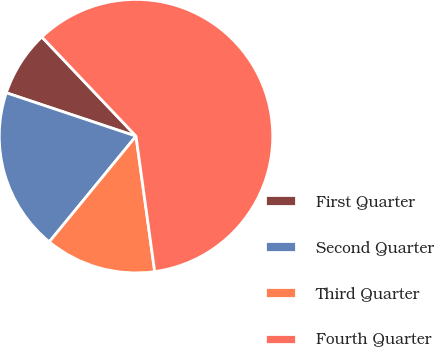Convert chart to OTSL. <chart><loc_0><loc_0><loc_500><loc_500><pie_chart><fcel>First Quarter<fcel>Second Quarter<fcel>Third Quarter<fcel>Fourth Quarter<nl><fcel>7.78%<fcel>19.2%<fcel>13.12%<fcel>59.9%<nl></chart> 